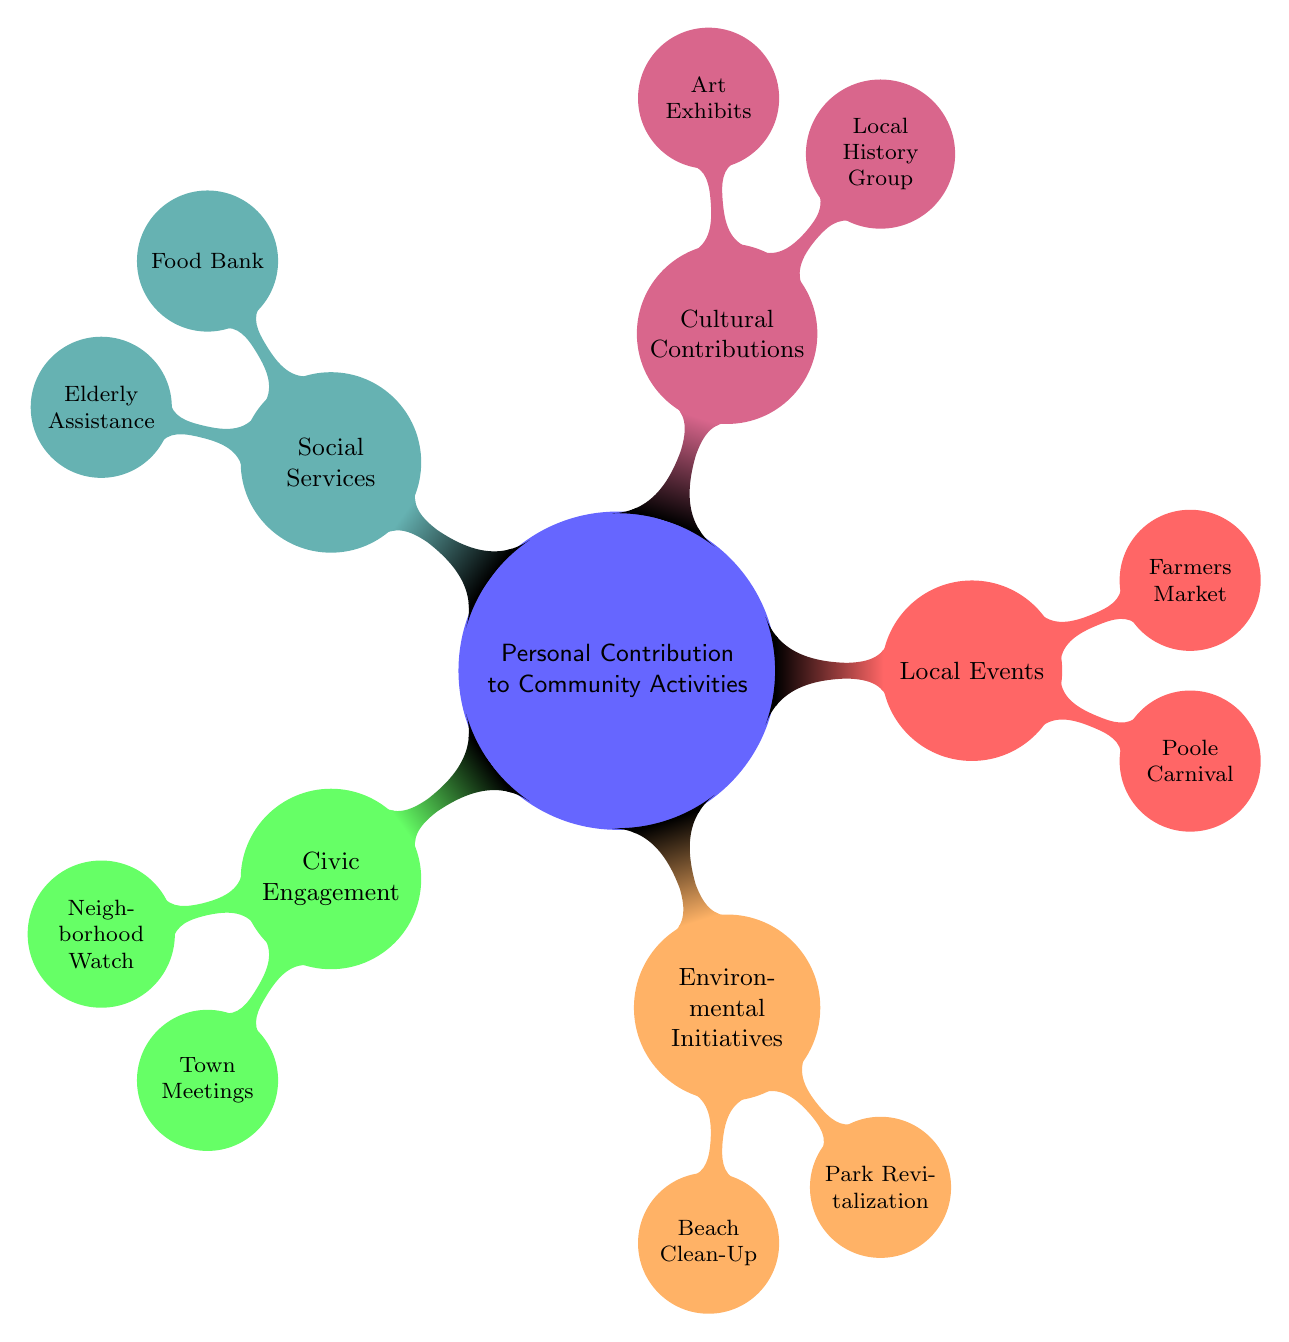What is the central theme of the mind map? The central theme is represented by the main node in the diagram, which states "Personal Contribution to Community Activities." This node encompasses all other aspects or categories around it, indicating the broad focus of this mind map.
Answer: Personal Contribution to Community Activities How many main categories are there in the diagram? By counting the first level child nodes connected to the central node, we see that there are five main categories: Civic Engagement, Environmental Initiatives, Local Events, Cultural Contributions, and Social Services.
Answer: 5 Which local event is associated with being a 'Committee Member'? The node labeled "Poole Carnival," located under the "Local Events" category, is specifically associated with the role of 'Committee Member.'
Answer: Poole Carnival What type of contribution can someone make in the Local History Group? The Local History Group includes roles like "Researcher" and "Documentarian," both denoting different types of contributions someone could make within this group.
Answer: Researcher, Documentarian What is one activity you can participate in for Environmental Initiatives? Among the listed activities under Environmental Initiatives, "Beach Clean-Up" is a prominent example where individuals can engage in community service to enhance the environment.
Answer: Beach Clean-Up Which category includes the 'Transport Provider' role? The "Social Services" category contains the 'Transport Provider' role, indicating its focus on assistance services provided to the community.
Answer: Social Services What are two roles mentioned for the Food Bank? Under the "Food Bank" node, the roles specified are 'Donor' and 'Volunteer,' both highlighting ways individuals can contribute to this service.
Answer: Donor, Volunteer Which activity has a role that is specifically labeled 'Gardener'? In the "Environmental Initiatives" category, under "Park Revitalization," the role of 'Gardener' is specifically mentioned as part of community contributions.
Answer: Park Revitalization Which two types of contributions are found in the Environmental Initiatives? The two types of contributions found under Environmental Initiatives are related to "Beach Clean-Up" and "Park Revitalization," representing different avenues for community involvement specifically in environmental projects.
Answer: Beach Clean-Up, Park Revitalization 